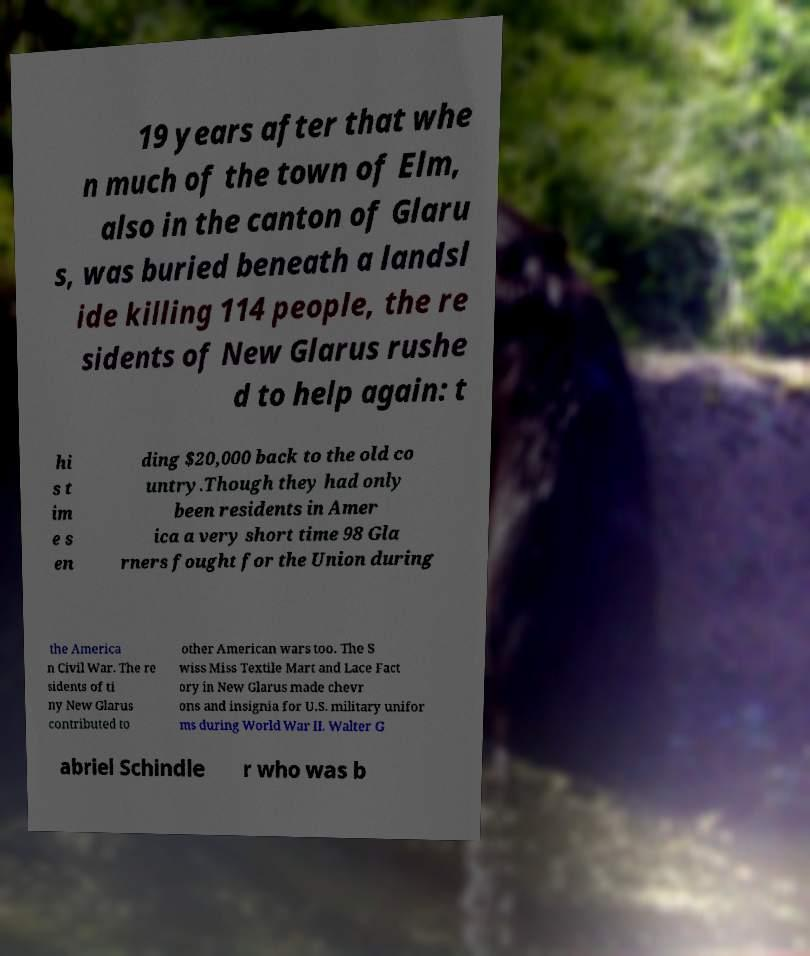Please read and relay the text visible in this image. What does it say? 19 years after that whe n much of the town of Elm, also in the canton of Glaru s, was buried beneath a landsl ide killing 114 people, the re sidents of New Glarus rushe d to help again: t hi s t im e s en ding $20,000 back to the old co untry.Though they had only been residents in Amer ica a very short time 98 Gla rners fought for the Union during the America n Civil War. The re sidents of ti ny New Glarus contributed to other American wars too. The S wiss Miss Textile Mart and Lace Fact ory in New Glarus made chevr ons and insignia for U.S. military unifor ms during World War II. Walter G abriel Schindle r who was b 